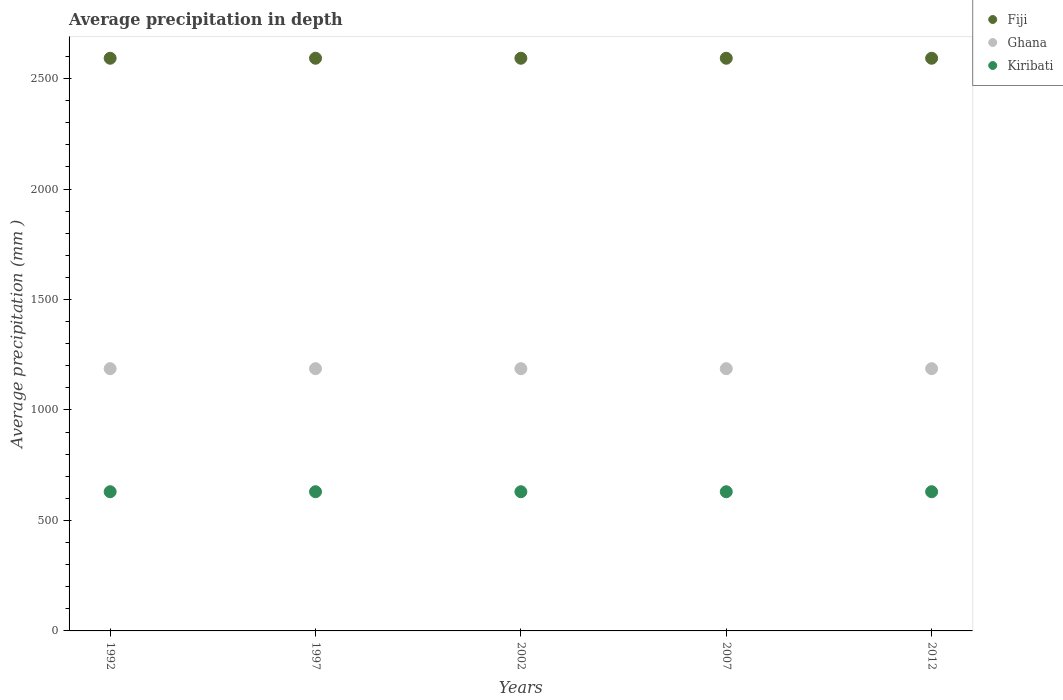What is the average precipitation in Kiribati in 2007?
Your answer should be compact. 630. Across all years, what is the maximum average precipitation in Fiji?
Keep it short and to the point. 2592. Across all years, what is the minimum average precipitation in Ghana?
Ensure brevity in your answer.  1187. In which year was the average precipitation in Kiribati maximum?
Your answer should be very brief. 1992. What is the total average precipitation in Fiji in the graph?
Make the answer very short. 1.30e+04. What is the difference between the average precipitation in Fiji in 2002 and the average precipitation in Kiribati in 2007?
Provide a short and direct response. 1962. What is the average average precipitation in Kiribati per year?
Give a very brief answer. 630. In the year 2007, what is the difference between the average precipitation in Kiribati and average precipitation in Fiji?
Keep it short and to the point. -1962. In how many years, is the average precipitation in Kiribati greater than 1300 mm?
Make the answer very short. 0. Is the average precipitation in Fiji in 1992 less than that in 2012?
Offer a very short reply. No. What is the difference between the highest and the second highest average precipitation in Kiribati?
Your response must be concise. 0. Is it the case that in every year, the sum of the average precipitation in Ghana and average precipitation in Fiji  is greater than the average precipitation in Kiribati?
Provide a short and direct response. Yes. Does the average precipitation in Fiji monotonically increase over the years?
Your response must be concise. No. Is the average precipitation in Ghana strictly greater than the average precipitation in Kiribati over the years?
Provide a succinct answer. Yes. Is the average precipitation in Fiji strictly less than the average precipitation in Ghana over the years?
Your answer should be very brief. No. How many dotlines are there?
Your response must be concise. 3. How many years are there in the graph?
Your response must be concise. 5. Are the values on the major ticks of Y-axis written in scientific E-notation?
Keep it short and to the point. No. Does the graph contain any zero values?
Keep it short and to the point. No. Does the graph contain grids?
Your response must be concise. No. Where does the legend appear in the graph?
Give a very brief answer. Top right. How many legend labels are there?
Provide a short and direct response. 3. What is the title of the graph?
Your answer should be compact. Average precipitation in depth. Does "Cyprus" appear as one of the legend labels in the graph?
Your answer should be very brief. No. What is the label or title of the Y-axis?
Your answer should be compact. Average precipitation (mm ). What is the Average precipitation (mm ) in Fiji in 1992?
Your response must be concise. 2592. What is the Average precipitation (mm ) of Ghana in 1992?
Make the answer very short. 1187. What is the Average precipitation (mm ) of Kiribati in 1992?
Your answer should be very brief. 630. What is the Average precipitation (mm ) in Fiji in 1997?
Make the answer very short. 2592. What is the Average precipitation (mm ) of Ghana in 1997?
Offer a terse response. 1187. What is the Average precipitation (mm ) of Kiribati in 1997?
Provide a succinct answer. 630. What is the Average precipitation (mm ) in Fiji in 2002?
Your answer should be compact. 2592. What is the Average precipitation (mm ) of Ghana in 2002?
Offer a terse response. 1187. What is the Average precipitation (mm ) of Kiribati in 2002?
Provide a short and direct response. 630. What is the Average precipitation (mm ) of Fiji in 2007?
Your answer should be compact. 2592. What is the Average precipitation (mm ) in Ghana in 2007?
Your answer should be compact. 1187. What is the Average precipitation (mm ) in Kiribati in 2007?
Ensure brevity in your answer.  630. What is the Average precipitation (mm ) in Fiji in 2012?
Your response must be concise. 2592. What is the Average precipitation (mm ) of Ghana in 2012?
Your answer should be very brief. 1187. What is the Average precipitation (mm ) of Kiribati in 2012?
Keep it short and to the point. 630. Across all years, what is the maximum Average precipitation (mm ) of Fiji?
Provide a short and direct response. 2592. Across all years, what is the maximum Average precipitation (mm ) in Ghana?
Your response must be concise. 1187. Across all years, what is the maximum Average precipitation (mm ) in Kiribati?
Your answer should be very brief. 630. Across all years, what is the minimum Average precipitation (mm ) of Fiji?
Give a very brief answer. 2592. Across all years, what is the minimum Average precipitation (mm ) in Ghana?
Your response must be concise. 1187. Across all years, what is the minimum Average precipitation (mm ) of Kiribati?
Keep it short and to the point. 630. What is the total Average precipitation (mm ) in Fiji in the graph?
Your answer should be very brief. 1.30e+04. What is the total Average precipitation (mm ) in Ghana in the graph?
Your response must be concise. 5935. What is the total Average precipitation (mm ) in Kiribati in the graph?
Your answer should be compact. 3150. What is the difference between the Average precipitation (mm ) of Kiribati in 1992 and that in 1997?
Your response must be concise. 0. What is the difference between the Average precipitation (mm ) in Kiribati in 1992 and that in 2002?
Offer a very short reply. 0. What is the difference between the Average precipitation (mm ) of Fiji in 1992 and that in 2007?
Offer a very short reply. 0. What is the difference between the Average precipitation (mm ) in Ghana in 1992 and that in 2007?
Your answer should be very brief. 0. What is the difference between the Average precipitation (mm ) in Kiribati in 1992 and that in 2007?
Offer a terse response. 0. What is the difference between the Average precipitation (mm ) of Ghana in 1992 and that in 2012?
Your response must be concise. 0. What is the difference between the Average precipitation (mm ) in Kiribati in 1992 and that in 2012?
Keep it short and to the point. 0. What is the difference between the Average precipitation (mm ) of Fiji in 1997 and that in 2007?
Your response must be concise. 0. What is the difference between the Average precipitation (mm ) of Kiribati in 1997 and that in 2007?
Your response must be concise. 0. What is the difference between the Average precipitation (mm ) in Fiji in 1997 and that in 2012?
Offer a very short reply. 0. What is the difference between the Average precipitation (mm ) of Ghana in 1997 and that in 2012?
Your response must be concise. 0. What is the difference between the Average precipitation (mm ) in Kiribati in 1997 and that in 2012?
Offer a terse response. 0. What is the difference between the Average precipitation (mm ) of Kiribati in 2002 and that in 2007?
Offer a terse response. 0. What is the difference between the Average precipitation (mm ) of Fiji in 2002 and that in 2012?
Your answer should be compact. 0. What is the difference between the Average precipitation (mm ) of Ghana in 2007 and that in 2012?
Your response must be concise. 0. What is the difference between the Average precipitation (mm ) in Kiribati in 2007 and that in 2012?
Provide a short and direct response. 0. What is the difference between the Average precipitation (mm ) of Fiji in 1992 and the Average precipitation (mm ) of Ghana in 1997?
Ensure brevity in your answer.  1405. What is the difference between the Average precipitation (mm ) of Fiji in 1992 and the Average precipitation (mm ) of Kiribati in 1997?
Ensure brevity in your answer.  1962. What is the difference between the Average precipitation (mm ) in Ghana in 1992 and the Average precipitation (mm ) in Kiribati in 1997?
Provide a succinct answer. 557. What is the difference between the Average precipitation (mm ) in Fiji in 1992 and the Average precipitation (mm ) in Ghana in 2002?
Your answer should be very brief. 1405. What is the difference between the Average precipitation (mm ) in Fiji in 1992 and the Average precipitation (mm ) in Kiribati in 2002?
Your answer should be compact. 1962. What is the difference between the Average precipitation (mm ) in Ghana in 1992 and the Average precipitation (mm ) in Kiribati in 2002?
Offer a terse response. 557. What is the difference between the Average precipitation (mm ) in Fiji in 1992 and the Average precipitation (mm ) in Ghana in 2007?
Your answer should be very brief. 1405. What is the difference between the Average precipitation (mm ) of Fiji in 1992 and the Average precipitation (mm ) of Kiribati in 2007?
Your response must be concise. 1962. What is the difference between the Average precipitation (mm ) in Ghana in 1992 and the Average precipitation (mm ) in Kiribati in 2007?
Ensure brevity in your answer.  557. What is the difference between the Average precipitation (mm ) of Fiji in 1992 and the Average precipitation (mm ) of Ghana in 2012?
Offer a very short reply. 1405. What is the difference between the Average precipitation (mm ) of Fiji in 1992 and the Average precipitation (mm ) of Kiribati in 2012?
Give a very brief answer. 1962. What is the difference between the Average precipitation (mm ) in Ghana in 1992 and the Average precipitation (mm ) in Kiribati in 2012?
Keep it short and to the point. 557. What is the difference between the Average precipitation (mm ) of Fiji in 1997 and the Average precipitation (mm ) of Ghana in 2002?
Your answer should be very brief. 1405. What is the difference between the Average precipitation (mm ) in Fiji in 1997 and the Average precipitation (mm ) in Kiribati in 2002?
Ensure brevity in your answer.  1962. What is the difference between the Average precipitation (mm ) in Ghana in 1997 and the Average precipitation (mm ) in Kiribati in 2002?
Offer a terse response. 557. What is the difference between the Average precipitation (mm ) in Fiji in 1997 and the Average precipitation (mm ) in Ghana in 2007?
Ensure brevity in your answer.  1405. What is the difference between the Average precipitation (mm ) in Fiji in 1997 and the Average precipitation (mm ) in Kiribati in 2007?
Your answer should be compact. 1962. What is the difference between the Average precipitation (mm ) in Ghana in 1997 and the Average precipitation (mm ) in Kiribati in 2007?
Your answer should be very brief. 557. What is the difference between the Average precipitation (mm ) in Fiji in 1997 and the Average precipitation (mm ) in Ghana in 2012?
Offer a terse response. 1405. What is the difference between the Average precipitation (mm ) of Fiji in 1997 and the Average precipitation (mm ) of Kiribati in 2012?
Your response must be concise. 1962. What is the difference between the Average precipitation (mm ) in Ghana in 1997 and the Average precipitation (mm ) in Kiribati in 2012?
Your answer should be compact. 557. What is the difference between the Average precipitation (mm ) of Fiji in 2002 and the Average precipitation (mm ) of Ghana in 2007?
Provide a short and direct response. 1405. What is the difference between the Average precipitation (mm ) of Fiji in 2002 and the Average precipitation (mm ) of Kiribati in 2007?
Your answer should be compact. 1962. What is the difference between the Average precipitation (mm ) in Ghana in 2002 and the Average precipitation (mm ) in Kiribati in 2007?
Ensure brevity in your answer.  557. What is the difference between the Average precipitation (mm ) in Fiji in 2002 and the Average precipitation (mm ) in Ghana in 2012?
Provide a succinct answer. 1405. What is the difference between the Average precipitation (mm ) in Fiji in 2002 and the Average precipitation (mm ) in Kiribati in 2012?
Provide a succinct answer. 1962. What is the difference between the Average precipitation (mm ) of Ghana in 2002 and the Average precipitation (mm ) of Kiribati in 2012?
Keep it short and to the point. 557. What is the difference between the Average precipitation (mm ) in Fiji in 2007 and the Average precipitation (mm ) in Ghana in 2012?
Keep it short and to the point. 1405. What is the difference between the Average precipitation (mm ) in Fiji in 2007 and the Average precipitation (mm ) in Kiribati in 2012?
Provide a short and direct response. 1962. What is the difference between the Average precipitation (mm ) of Ghana in 2007 and the Average precipitation (mm ) of Kiribati in 2012?
Offer a terse response. 557. What is the average Average precipitation (mm ) in Fiji per year?
Your answer should be very brief. 2592. What is the average Average precipitation (mm ) of Ghana per year?
Your answer should be very brief. 1187. What is the average Average precipitation (mm ) of Kiribati per year?
Keep it short and to the point. 630. In the year 1992, what is the difference between the Average precipitation (mm ) in Fiji and Average precipitation (mm ) in Ghana?
Keep it short and to the point. 1405. In the year 1992, what is the difference between the Average precipitation (mm ) in Fiji and Average precipitation (mm ) in Kiribati?
Ensure brevity in your answer.  1962. In the year 1992, what is the difference between the Average precipitation (mm ) in Ghana and Average precipitation (mm ) in Kiribati?
Your answer should be very brief. 557. In the year 1997, what is the difference between the Average precipitation (mm ) of Fiji and Average precipitation (mm ) of Ghana?
Your answer should be compact. 1405. In the year 1997, what is the difference between the Average precipitation (mm ) in Fiji and Average precipitation (mm ) in Kiribati?
Offer a very short reply. 1962. In the year 1997, what is the difference between the Average precipitation (mm ) of Ghana and Average precipitation (mm ) of Kiribati?
Provide a succinct answer. 557. In the year 2002, what is the difference between the Average precipitation (mm ) in Fiji and Average precipitation (mm ) in Ghana?
Provide a succinct answer. 1405. In the year 2002, what is the difference between the Average precipitation (mm ) in Fiji and Average precipitation (mm ) in Kiribati?
Offer a terse response. 1962. In the year 2002, what is the difference between the Average precipitation (mm ) of Ghana and Average precipitation (mm ) of Kiribati?
Give a very brief answer. 557. In the year 2007, what is the difference between the Average precipitation (mm ) in Fiji and Average precipitation (mm ) in Ghana?
Provide a succinct answer. 1405. In the year 2007, what is the difference between the Average precipitation (mm ) in Fiji and Average precipitation (mm ) in Kiribati?
Your answer should be very brief. 1962. In the year 2007, what is the difference between the Average precipitation (mm ) in Ghana and Average precipitation (mm ) in Kiribati?
Your answer should be compact. 557. In the year 2012, what is the difference between the Average precipitation (mm ) of Fiji and Average precipitation (mm ) of Ghana?
Give a very brief answer. 1405. In the year 2012, what is the difference between the Average precipitation (mm ) in Fiji and Average precipitation (mm ) in Kiribati?
Provide a succinct answer. 1962. In the year 2012, what is the difference between the Average precipitation (mm ) in Ghana and Average precipitation (mm ) in Kiribati?
Make the answer very short. 557. What is the ratio of the Average precipitation (mm ) of Fiji in 1992 to that in 1997?
Offer a terse response. 1. What is the ratio of the Average precipitation (mm ) in Kiribati in 1992 to that in 1997?
Your answer should be very brief. 1. What is the ratio of the Average precipitation (mm ) in Ghana in 1992 to that in 2002?
Make the answer very short. 1. What is the ratio of the Average precipitation (mm ) in Kiribati in 1992 to that in 2002?
Keep it short and to the point. 1. What is the ratio of the Average precipitation (mm ) of Fiji in 1992 to that in 2007?
Ensure brevity in your answer.  1. What is the ratio of the Average precipitation (mm ) of Kiribati in 1992 to that in 2007?
Offer a very short reply. 1. What is the ratio of the Average precipitation (mm ) in Fiji in 1992 to that in 2012?
Ensure brevity in your answer.  1. What is the ratio of the Average precipitation (mm ) in Fiji in 1997 to that in 2007?
Provide a succinct answer. 1. What is the ratio of the Average precipitation (mm ) of Ghana in 1997 to that in 2007?
Provide a short and direct response. 1. What is the ratio of the Average precipitation (mm ) of Ghana in 1997 to that in 2012?
Your answer should be very brief. 1. What is the ratio of the Average precipitation (mm ) of Kiribati in 1997 to that in 2012?
Provide a short and direct response. 1. What is the ratio of the Average precipitation (mm ) in Fiji in 2002 to that in 2007?
Give a very brief answer. 1. What is the ratio of the Average precipitation (mm ) of Ghana in 2002 to that in 2007?
Provide a short and direct response. 1. What is the ratio of the Average precipitation (mm ) in Kiribati in 2002 to that in 2007?
Give a very brief answer. 1. What is the ratio of the Average precipitation (mm ) in Kiribati in 2002 to that in 2012?
Offer a very short reply. 1. What is the ratio of the Average precipitation (mm ) of Fiji in 2007 to that in 2012?
Provide a short and direct response. 1. What is the difference between the highest and the second highest Average precipitation (mm ) of Fiji?
Keep it short and to the point. 0. What is the difference between the highest and the second highest Average precipitation (mm ) of Kiribati?
Your answer should be compact. 0. What is the difference between the highest and the lowest Average precipitation (mm ) in Fiji?
Make the answer very short. 0. What is the difference between the highest and the lowest Average precipitation (mm ) of Ghana?
Your answer should be compact. 0. 